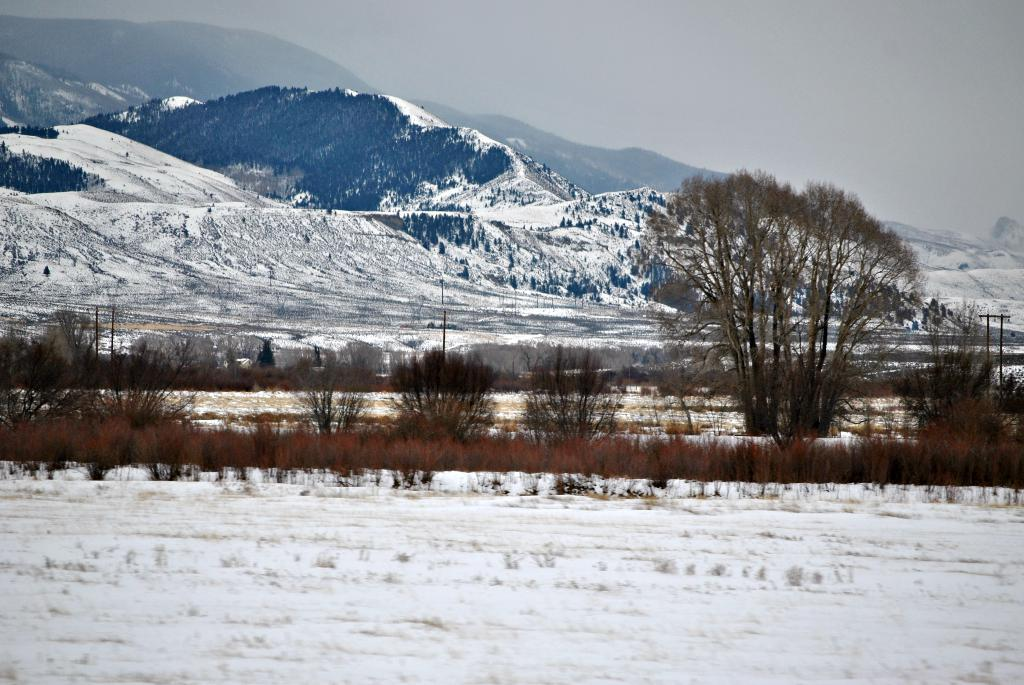What type of terrain is visible in the image? There are hills in the image. What type of vegetation can be seen in the image? There are trees and plants in the image. What is covering the ground in the image? The ground is covered with snow. What structures are present in the image? There are poles in the image. What part of the natural environment is visible in the image? The sky is visible in the image. What order are the plants arranged in the image? The plants in the image are not arranged in any specific order; they are randomly distributed. What is the starting point for the plants in the image? There is no starting point for the plants in the image, as they are not arranged in a specific pattern or order. 